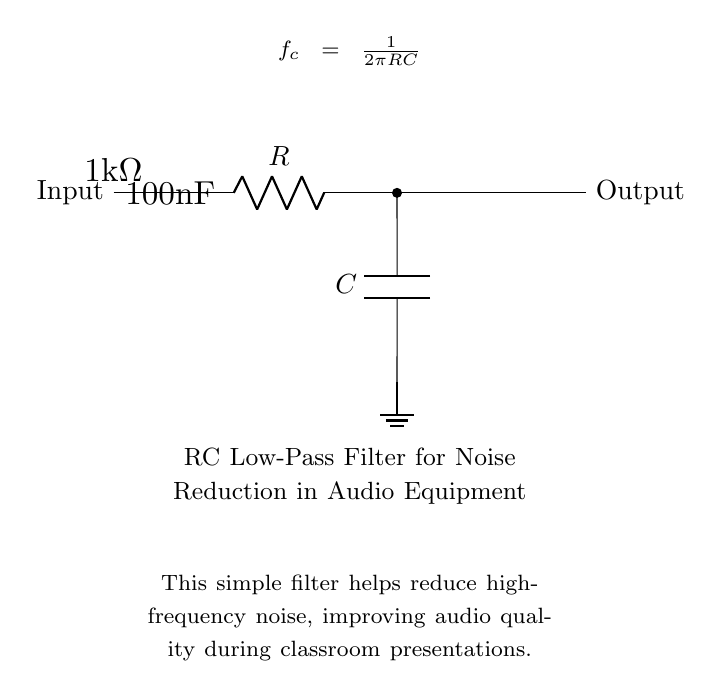What type of circuit is this? This circuit is an RC low-pass filter, as indicated by the resistor (R) and capacitor (C) components arranged to reduce high-frequency signals while allowing low-frequency signals to pass.
Answer: RC low-pass filter What is the resistance value in this circuit? The resistance in the circuit is indicated as 1kΩ, which is shown clearly next to the resistor symbol in the circuit diagram.
Answer: 1kΩ What is the capacitance value in this circuit? The capacitance is labeled as 100nF, which can be found next to the capacitor symbol in the circuit diagram.
Answer: 100nF What is the purpose of this circuit? The purpose of this RC low-pass filter circuit is to reduce high-frequency noise, improving audio quality during presentations, as noted in the explanation below the circuit.
Answer: Reduce noise What is the cutoff frequency formula for this filter? The cutoff frequency formula is f_c = 1/(2πRC), which is shown in the diagram as a mathematical representation utilized to determine the frequency at which the output signal starts to decrease.
Answer: 1/(2πRC) What happens to high-frequency signals in this circuit? High-frequency signals are attenuated or reduced in amplitude when they pass through this RC low-pass filter, which allows primarily low-frequency signals to be transmitted effectively.
Answer: Attenuated How does this circuit improve audio quality during presentations? By filtering out unwanted high-frequency noise, the circuit helps to maintain clarity in the audio signal, ensuring that the essential information is heard clearly during presentations, as described in the explanation accompanying the circuit diagram.
Answer: Maintains clarity 